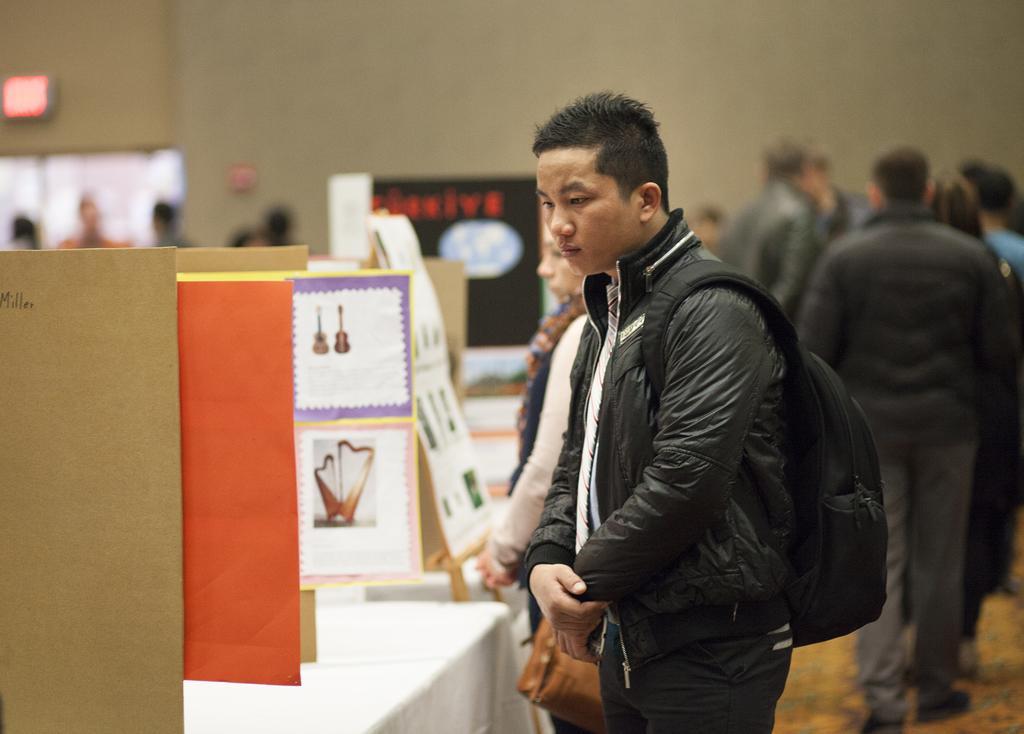How would you summarize this image in a sentence or two? Here we can see few persons standing at the hoardings which are on the tables. In the background the image is blur but we can see few persons,wall,hoardings and other objects. 